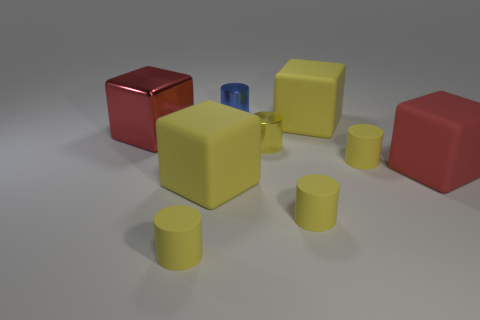The big red rubber object has what shape?
Offer a very short reply. Cube. There is a small metallic object that is behind the yellow block that is behind the large metallic block; what color is it?
Your answer should be very brief. Blue. There is a yellow rubber cube on the left side of the blue metal cylinder; how big is it?
Provide a short and direct response. Large. Is there a purple thing made of the same material as the tiny blue thing?
Keep it short and to the point. No. How many small blue metallic objects are the same shape as the small yellow metallic object?
Offer a very short reply. 1. The big yellow rubber object that is behind the yellow cube on the left side of the large yellow matte object that is to the right of the blue object is what shape?
Your response must be concise. Cube. There is a large block that is behind the tiny yellow metal cylinder and on the right side of the red metal cube; what material is it?
Give a very brief answer. Rubber. Is the size of the red block on the right side of the blue object the same as the blue metallic object?
Offer a very short reply. No. Are there more big red things to the right of the tiny yellow metallic cylinder than red matte cubes that are to the left of the red matte cube?
Offer a very short reply. Yes. There is a matte cylinder that is behind the big yellow cube on the left side of the small metal object that is in front of the large metal thing; what is its color?
Provide a succinct answer. Yellow. 